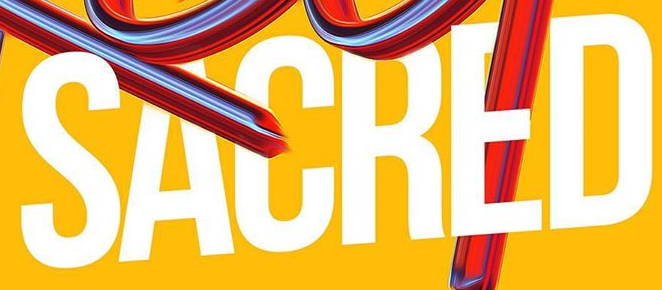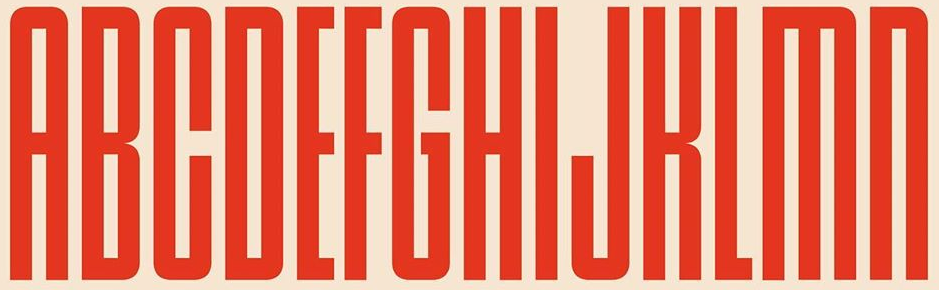What words can you see in these images in sequence, separated by a semicolon? SACRED; ABCDEFGHIJKLMN 